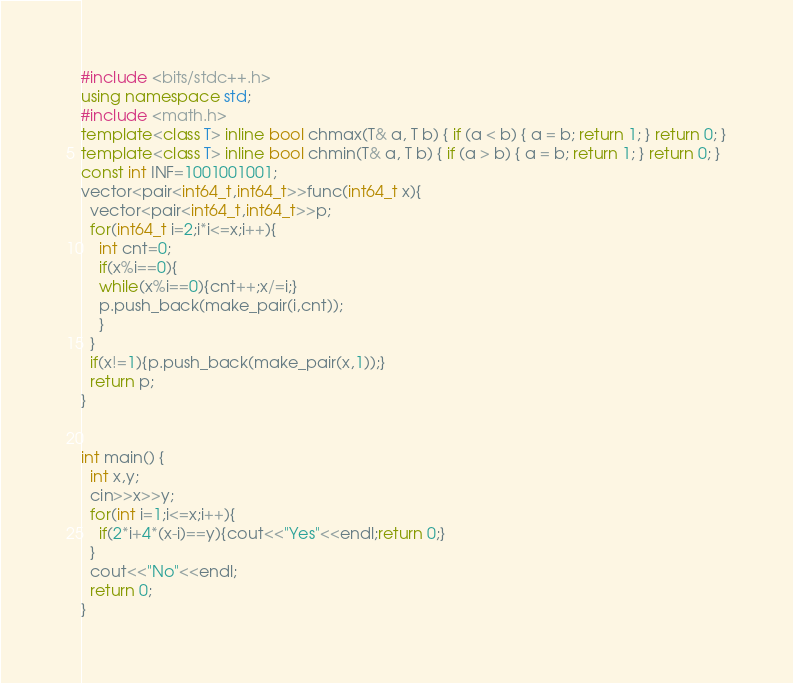Convert code to text. <code><loc_0><loc_0><loc_500><loc_500><_C++_>#include <bits/stdc++.h>
using namespace std;
#include <math.h>
template<class T> inline bool chmax(T& a, T b) { if (a < b) { a = b; return 1; } return 0; }
template<class T> inline bool chmin(T& a, T b) { if (a > b) { a = b; return 1; } return 0; }
const int INF=1001001001;
vector<pair<int64_t,int64_t>>func(int64_t x){
  vector<pair<int64_t,int64_t>>p;
  for(int64_t i=2;i*i<=x;i++){
    int cnt=0;
    if(x%i==0){
    while(x%i==0){cnt++;x/=i;}
    p.push_back(make_pair(i,cnt));
    }
  }
  if(x!=1){p.push_back(make_pair(x,1));}
  return p;
}


int main() {
  int x,y;
  cin>>x>>y;
  for(int i=1;i<=x;i++){
    if(2*i+4*(x-i)==y){cout<<"Yes"<<endl;return 0;}
  }
  cout<<"No"<<endl;
  return 0;
}</code> 